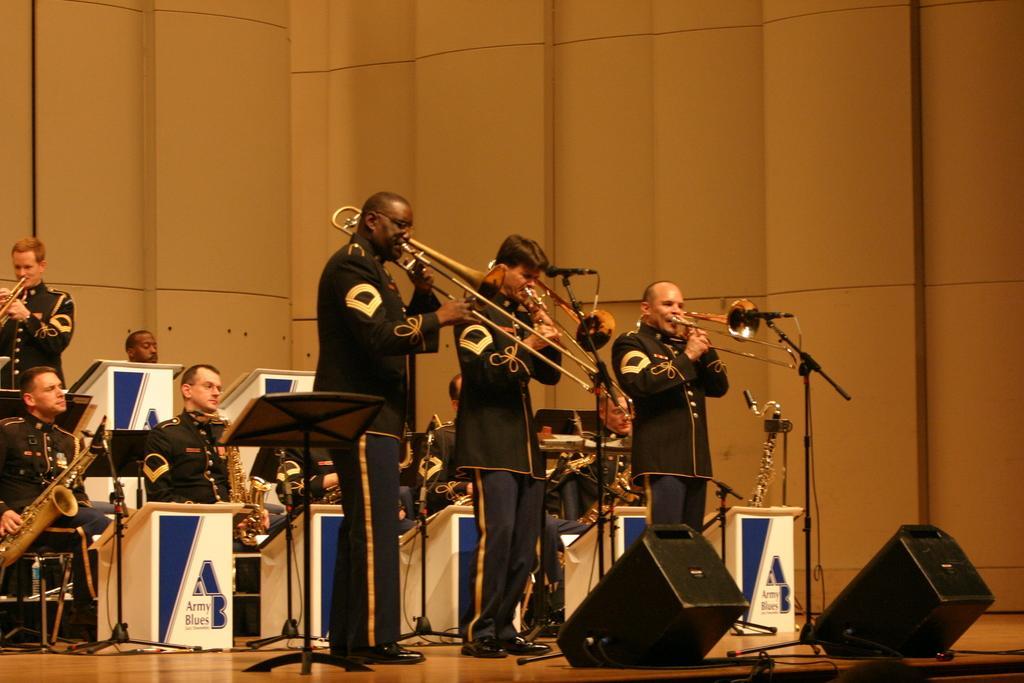Please provide a concise description of this image. In the picture I can see a group of people and they are holding the musical instruments. I can see a few of them standing and a few of them sitting on the chairs. 